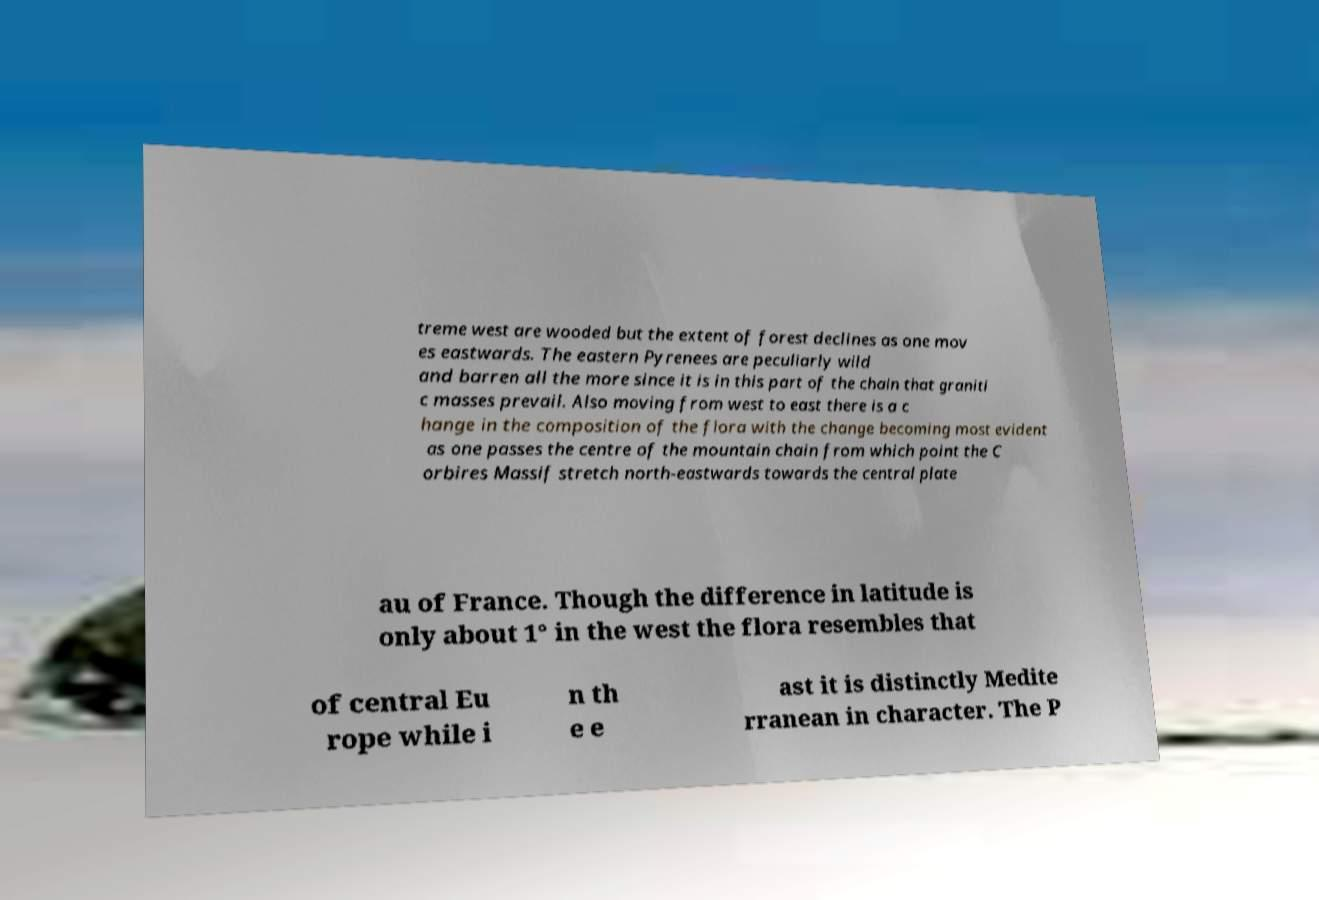Could you extract and type out the text from this image? treme west are wooded but the extent of forest declines as one mov es eastwards. The eastern Pyrenees are peculiarly wild and barren all the more since it is in this part of the chain that graniti c masses prevail. Also moving from west to east there is a c hange in the composition of the flora with the change becoming most evident as one passes the centre of the mountain chain from which point the C orbires Massif stretch north-eastwards towards the central plate au of France. Though the difference in latitude is only about 1° in the west the flora resembles that of central Eu rope while i n th e e ast it is distinctly Medite rranean in character. The P 